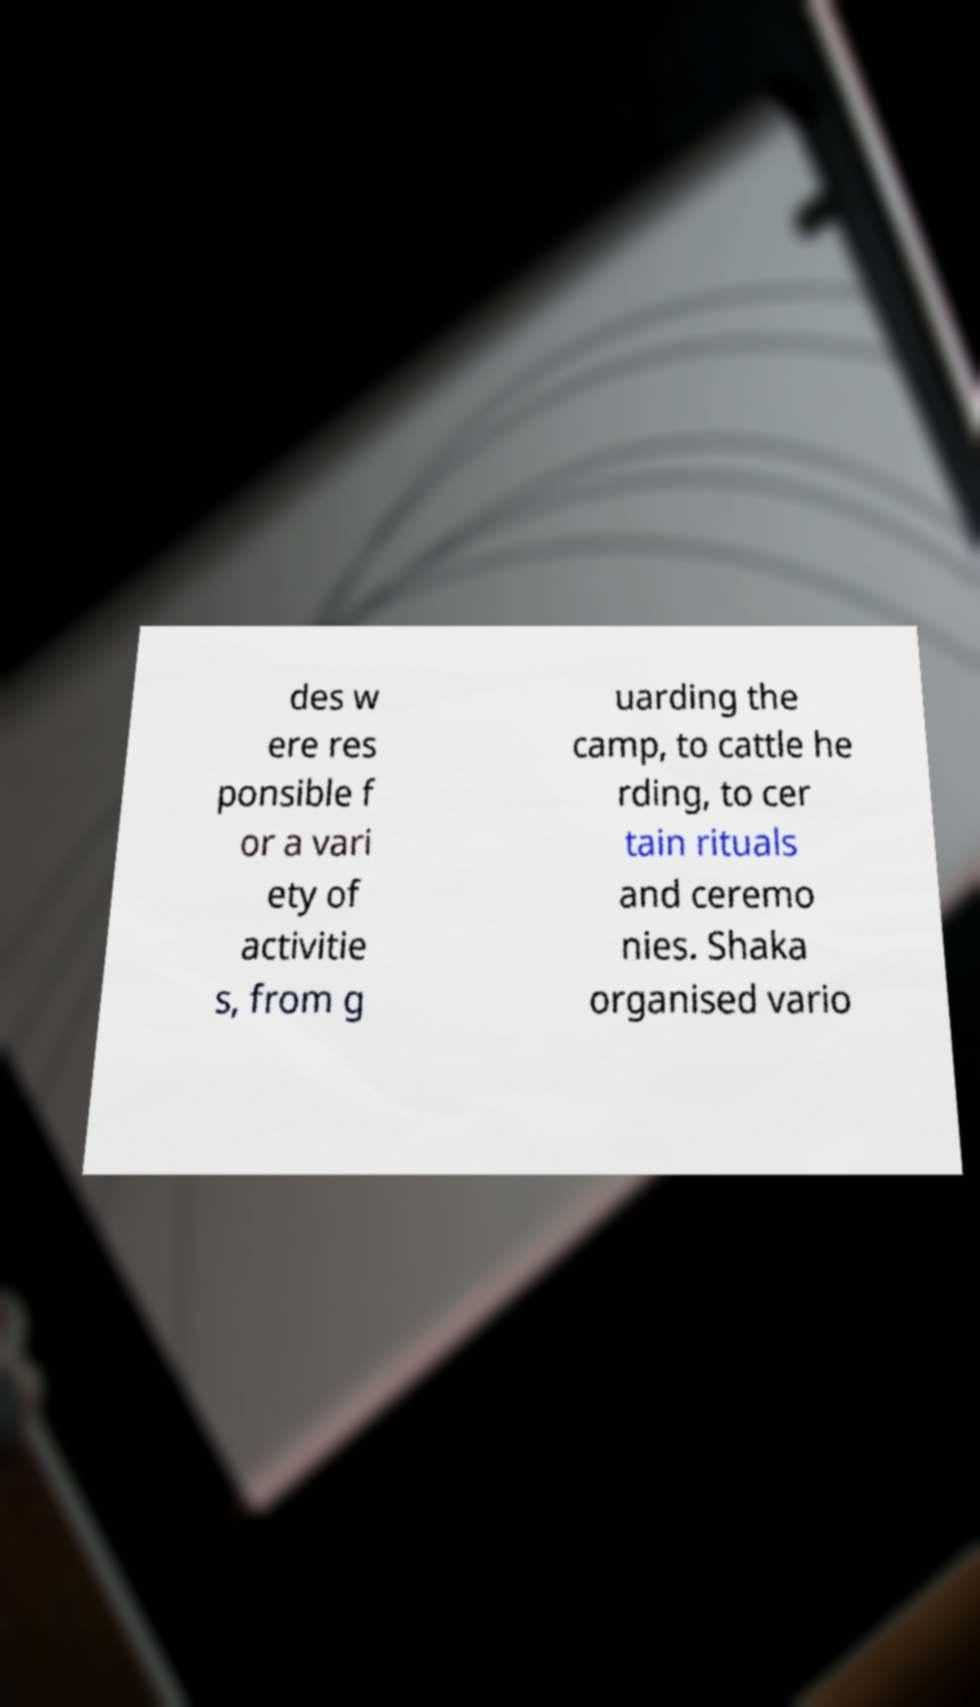What messages or text are displayed in this image? I need them in a readable, typed format. des w ere res ponsible f or a vari ety of activitie s, from g uarding the camp, to cattle he rding, to cer tain rituals and ceremo nies. Shaka organised vario 